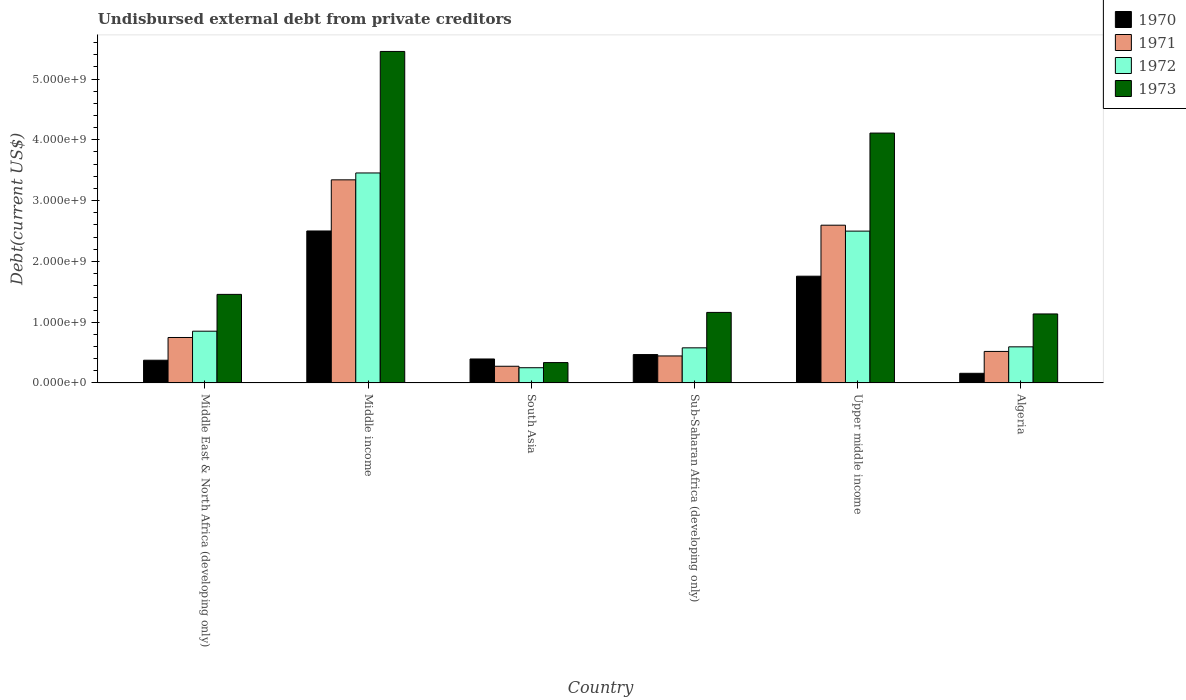Are the number of bars per tick equal to the number of legend labels?
Offer a very short reply. Yes. Are the number of bars on each tick of the X-axis equal?
Give a very brief answer. Yes. How many bars are there on the 5th tick from the right?
Offer a very short reply. 4. What is the label of the 6th group of bars from the left?
Ensure brevity in your answer.  Algeria. What is the total debt in 1973 in Middle East & North Africa (developing only)?
Give a very brief answer. 1.46e+09. Across all countries, what is the maximum total debt in 1973?
Ensure brevity in your answer.  5.45e+09. Across all countries, what is the minimum total debt in 1970?
Ensure brevity in your answer.  1.59e+08. In which country was the total debt in 1973 maximum?
Give a very brief answer. Middle income. In which country was the total debt in 1971 minimum?
Your answer should be compact. South Asia. What is the total total debt in 1970 in the graph?
Your response must be concise. 5.65e+09. What is the difference between the total debt in 1971 in South Asia and that in Upper middle income?
Your answer should be very brief. -2.32e+09. What is the difference between the total debt in 1973 in South Asia and the total debt in 1971 in Middle income?
Make the answer very short. -3.01e+09. What is the average total debt in 1972 per country?
Make the answer very short. 1.37e+09. What is the difference between the total debt of/in 1971 and total debt of/in 1970 in Upper middle income?
Your answer should be compact. 8.39e+08. In how many countries, is the total debt in 1973 greater than 2600000000 US$?
Ensure brevity in your answer.  2. What is the ratio of the total debt in 1972 in Middle income to that in Upper middle income?
Keep it short and to the point. 1.38. Is the difference between the total debt in 1971 in Middle East & North Africa (developing only) and Middle income greater than the difference between the total debt in 1970 in Middle East & North Africa (developing only) and Middle income?
Your answer should be compact. No. What is the difference between the highest and the second highest total debt in 1971?
Provide a short and direct response. -7.46e+08. What is the difference between the highest and the lowest total debt in 1971?
Make the answer very short. 3.07e+09. Is the sum of the total debt in 1971 in South Asia and Upper middle income greater than the maximum total debt in 1970 across all countries?
Keep it short and to the point. Yes. What does the 3rd bar from the left in Upper middle income represents?
Keep it short and to the point. 1972. What does the 4th bar from the right in South Asia represents?
Your response must be concise. 1970. Is it the case that in every country, the sum of the total debt in 1973 and total debt in 1970 is greater than the total debt in 1971?
Make the answer very short. Yes. What is the difference between two consecutive major ticks on the Y-axis?
Offer a terse response. 1.00e+09. Does the graph contain any zero values?
Your answer should be compact. No. Where does the legend appear in the graph?
Provide a short and direct response. Top right. How are the legend labels stacked?
Ensure brevity in your answer.  Vertical. What is the title of the graph?
Your answer should be compact. Undisbursed external debt from private creditors. Does "1968" appear as one of the legend labels in the graph?
Provide a succinct answer. No. What is the label or title of the X-axis?
Your answer should be compact. Country. What is the label or title of the Y-axis?
Make the answer very short. Debt(current US$). What is the Debt(current US$) in 1970 in Middle East & North Africa (developing only)?
Your response must be concise. 3.74e+08. What is the Debt(current US$) of 1971 in Middle East & North Africa (developing only)?
Offer a very short reply. 7.48e+08. What is the Debt(current US$) of 1972 in Middle East & North Africa (developing only)?
Offer a terse response. 8.51e+08. What is the Debt(current US$) in 1973 in Middle East & North Africa (developing only)?
Provide a succinct answer. 1.46e+09. What is the Debt(current US$) of 1970 in Middle income?
Ensure brevity in your answer.  2.50e+09. What is the Debt(current US$) of 1971 in Middle income?
Keep it short and to the point. 3.34e+09. What is the Debt(current US$) of 1972 in Middle income?
Offer a very short reply. 3.45e+09. What is the Debt(current US$) of 1973 in Middle income?
Your answer should be very brief. 5.45e+09. What is the Debt(current US$) of 1970 in South Asia?
Keep it short and to the point. 3.94e+08. What is the Debt(current US$) in 1971 in South Asia?
Provide a succinct answer. 2.74e+08. What is the Debt(current US$) in 1972 in South Asia?
Your answer should be compact. 2.50e+08. What is the Debt(current US$) of 1973 in South Asia?
Offer a terse response. 3.35e+08. What is the Debt(current US$) of 1970 in Sub-Saharan Africa (developing only)?
Offer a very short reply. 4.67e+08. What is the Debt(current US$) of 1971 in Sub-Saharan Africa (developing only)?
Make the answer very short. 4.44e+08. What is the Debt(current US$) of 1972 in Sub-Saharan Africa (developing only)?
Give a very brief answer. 5.77e+08. What is the Debt(current US$) in 1973 in Sub-Saharan Africa (developing only)?
Offer a very short reply. 1.16e+09. What is the Debt(current US$) of 1970 in Upper middle income?
Provide a short and direct response. 1.76e+09. What is the Debt(current US$) of 1971 in Upper middle income?
Give a very brief answer. 2.60e+09. What is the Debt(current US$) of 1972 in Upper middle income?
Offer a very short reply. 2.50e+09. What is the Debt(current US$) in 1973 in Upper middle income?
Your response must be concise. 4.11e+09. What is the Debt(current US$) of 1970 in Algeria?
Your response must be concise. 1.59e+08. What is the Debt(current US$) of 1971 in Algeria?
Keep it short and to the point. 5.18e+08. What is the Debt(current US$) in 1972 in Algeria?
Give a very brief answer. 5.94e+08. What is the Debt(current US$) of 1973 in Algeria?
Offer a very short reply. 1.14e+09. Across all countries, what is the maximum Debt(current US$) of 1970?
Offer a very short reply. 2.50e+09. Across all countries, what is the maximum Debt(current US$) of 1971?
Your answer should be very brief. 3.34e+09. Across all countries, what is the maximum Debt(current US$) of 1972?
Provide a succinct answer. 3.45e+09. Across all countries, what is the maximum Debt(current US$) in 1973?
Ensure brevity in your answer.  5.45e+09. Across all countries, what is the minimum Debt(current US$) in 1970?
Your response must be concise. 1.59e+08. Across all countries, what is the minimum Debt(current US$) in 1971?
Your response must be concise. 2.74e+08. Across all countries, what is the minimum Debt(current US$) in 1972?
Offer a terse response. 2.50e+08. Across all countries, what is the minimum Debt(current US$) of 1973?
Your answer should be compact. 3.35e+08. What is the total Debt(current US$) of 1970 in the graph?
Give a very brief answer. 5.65e+09. What is the total Debt(current US$) in 1971 in the graph?
Ensure brevity in your answer.  7.92e+09. What is the total Debt(current US$) of 1972 in the graph?
Provide a short and direct response. 8.23e+09. What is the total Debt(current US$) of 1973 in the graph?
Your response must be concise. 1.37e+1. What is the difference between the Debt(current US$) of 1970 in Middle East & North Africa (developing only) and that in Middle income?
Ensure brevity in your answer.  -2.13e+09. What is the difference between the Debt(current US$) of 1971 in Middle East & North Africa (developing only) and that in Middle income?
Your response must be concise. -2.59e+09. What is the difference between the Debt(current US$) of 1972 in Middle East & North Africa (developing only) and that in Middle income?
Provide a short and direct response. -2.60e+09. What is the difference between the Debt(current US$) of 1973 in Middle East & North Africa (developing only) and that in Middle income?
Give a very brief answer. -4.00e+09. What is the difference between the Debt(current US$) in 1970 in Middle East & North Africa (developing only) and that in South Asia?
Ensure brevity in your answer.  -2.07e+07. What is the difference between the Debt(current US$) of 1971 in Middle East & North Africa (developing only) and that in South Asia?
Provide a succinct answer. 4.74e+08. What is the difference between the Debt(current US$) in 1972 in Middle East & North Africa (developing only) and that in South Asia?
Your answer should be compact. 6.01e+08. What is the difference between the Debt(current US$) of 1973 in Middle East & North Africa (developing only) and that in South Asia?
Provide a succinct answer. 1.12e+09. What is the difference between the Debt(current US$) in 1970 in Middle East & North Africa (developing only) and that in Sub-Saharan Africa (developing only)?
Your response must be concise. -9.32e+07. What is the difference between the Debt(current US$) in 1971 in Middle East & North Africa (developing only) and that in Sub-Saharan Africa (developing only)?
Ensure brevity in your answer.  3.04e+08. What is the difference between the Debt(current US$) of 1972 in Middle East & North Africa (developing only) and that in Sub-Saharan Africa (developing only)?
Give a very brief answer. 2.74e+08. What is the difference between the Debt(current US$) of 1973 in Middle East & North Africa (developing only) and that in Sub-Saharan Africa (developing only)?
Provide a succinct answer. 2.97e+08. What is the difference between the Debt(current US$) of 1970 in Middle East & North Africa (developing only) and that in Upper middle income?
Make the answer very short. -1.38e+09. What is the difference between the Debt(current US$) of 1971 in Middle East & North Africa (developing only) and that in Upper middle income?
Your response must be concise. -1.85e+09. What is the difference between the Debt(current US$) of 1972 in Middle East & North Africa (developing only) and that in Upper middle income?
Give a very brief answer. -1.65e+09. What is the difference between the Debt(current US$) of 1973 in Middle East & North Africa (developing only) and that in Upper middle income?
Give a very brief answer. -2.65e+09. What is the difference between the Debt(current US$) in 1970 in Middle East & North Africa (developing only) and that in Algeria?
Offer a terse response. 2.15e+08. What is the difference between the Debt(current US$) in 1971 in Middle East & North Africa (developing only) and that in Algeria?
Give a very brief answer. 2.29e+08. What is the difference between the Debt(current US$) in 1972 in Middle East & North Africa (developing only) and that in Algeria?
Offer a terse response. 2.57e+08. What is the difference between the Debt(current US$) in 1973 in Middle East & North Africa (developing only) and that in Algeria?
Offer a terse response. 3.22e+08. What is the difference between the Debt(current US$) in 1970 in Middle income and that in South Asia?
Your answer should be very brief. 2.11e+09. What is the difference between the Debt(current US$) of 1971 in Middle income and that in South Asia?
Offer a very short reply. 3.07e+09. What is the difference between the Debt(current US$) in 1972 in Middle income and that in South Asia?
Ensure brevity in your answer.  3.20e+09. What is the difference between the Debt(current US$) of 1973 in Middle income and that in South Asia?
Keep it short and to the point. 5.12e+09. What is the difference between the Debt(current US$) in 1970 in Middle income and that in Sub-Saharan Africa (developing only)?
Your answer should be very brief. 2.03e+09. What is the difference between the Debt(current US$) in 1971 in Middle income and that in Sub-Saharan Africa (developing only)?
Your response must be concise. 2.90e+09. What is the difference between the Debt(current US$) in 1972 in Middle income and that in Sub-Saharan Africa (developing only)?
Your response must be concise. 2.88e+09. What is the difference between the Debt(current US$) in 1973 in Middle income and that in Sub-Saharan Africa (developing only)?
Keep it short and to the point. 4.29e+09. What is the difference between the Debt(current US$) in 1970 in Middle income and that in Upper middle income?
Offer a terse response. 7.44e+08. What is the difference between the Debt(current US$) in 1971 in Middle income and that in Upper middle income?
Offer a very short reply. 7.46e+08. What is the difference between the Debt(current US$) in 1972 in Middle income and that in Upper middle income?
Provide a succinct answer. 9.57e+08. What is the difference between the Debt(current US$) in 1973 in Middle income and that in Upper middle income?
Offer a very short reply. 1.34e+09. What is the difference between the Debt(current US$) of 1970 in Middle income and that in Algeria?
Give a very brief answer. 2.34e+09. What is the difference between the Debt(current US$) in 1971 in Middle income and that in Algeria?
Offer a very short reply. 2.82e+09. What is the difference between the Debt(current US$) in 1972 in Middle income and that in Algeria?
Provide a succinct answer. 2.86e+09. What is the difference between the Debt(current US$) of 1973 in Middle income and that in Algeria?
Keep it short and to the point. 4.32e+09. What is the difference between the Debt(current US$) of 1970 in South Asia and that in Sub-Saharan Africa (developing only)?
Make the answer very short. -7.26e+07. What is the difference between the Debt(current US$) of 1971 in South Asia and that in Sub-Saharan Africa (developing only)?
Offer a very short reply. -1.70e+08. What is the difference between the Debt(current US$) of 1972 in South Asia and that in Sub-Saharan Africa (developing only)?
Your answer should be compact. -3.27e+08. What is the difference between the Debt(current US$) of 1973 in South Asia and that in Sub-Saharan Africa (developing only)?
Offer a very short reply. -8.26e+08. What is the difference between the Debt(current US$) in 1970 in South Asia and that in Upper middle income?
Your answer should be very brief. -1.36e+09. What is the difference between the Debt(current US$) of 1971 in South Asia and that in Upper middle income?
Your answer should be compact. -2.32e+09. What is the difference between the Debt(current US$) in 1972 in South Asia and that in Upper middle income?
Your answer should be compact. -2.25e+09. What is the difference between the Debt(current US$) in 1973 in South Asia and that in Upper middle income?
Your answer should be very brief. -3.78e+09. What is the difference between the Debt(current US$) in 1970 in South Asia and that in Algeria?
Ensure brevity in your answer.  2.36e+08. What is the difference between the Debt(current US$) of 1971 in South Asia and that in Algeria?
Keep it short and to the point. -2.44e+08. What is the difference between the Debt(current US$) of 1972 in South Asia and that in Algeria?
Offer a very short reply. -3.44e+08. What is the difference between the Debt(current US$) of 1973 in South Asia and that in Algeria?
Offer a terse response. -8.00e+08. What is the difference between the Debt(current US$) in 1970 in Sub-Saharan Africa (developing only) and that in Upper middle income?
Offer a terse response. -1.29e+09. What is the difference between the Debt(current US$) of 1971 in Sub-Saharan Africa (developing only) and that in Upper middle income?
Offer a very short reply. -2.15e+09. What is the difference between the Debt(current US$) in 1972 in Sub-Saharan Africa (developing only) and that in Upper middle income?
Provide a succinct answer. -1.92e+09. What is the difference between the Debt(current US$) of 1973 in Sub-Saharan Africa (developing only) and that in Upper middle income?
Make the answer very short. -2.95e+09. What is the difference between the Debt(current US$) in 1970 in Sub-Saharan Africa (developing only) and that in Algeria?
Your response must be concise. 3.08e+08. What is the difference between the Debt(current US$) of 1971 in Sub-Saharan Africa (developing only) and that in Algeria?
Your answer should be compact. -7.44e+07. What is the difference between the Debt(current US$) of 1972 in Sub-Saharan Africa (developing only) and that in Algeria?
Provide a succinct answer. -1.64e+07. What is the difference between the Debt(current US$) of 1973 in Sub-Saharan Africa (developing only) and that in Algeria?
Offer a terse response. 2.52e+07. What is the difference between the Debt(current US$) of 1970 in Upper middle income and that in Algeria?
Keep it short and to the point. 1.60e+09. What is the difference between the Debt(current US$) of 1971 in Upper middle income and that in Algeria?
Offer a very short reply. 2.08e+09. What is the difference between the Debt(current US$) in 1972 in Upper middle income and that in Algeria?
Your answer should be very brief. 1.90e+09. What is the difference between the Debt(current US$) of 1973 in Upper middle income and that in Algeria?
Make the answer very short. 2.98e+09. What is the difference between the Debt(current US$) of 1970 in Middle East & North Africa (developing only) and the Debt(current US$) of 1971 in Middle income?
Offer a very short reply. -2.97e+09. What is the difference between the Debt(current US$) of 1970 in Middle East & North Africa (developing only) and the Debt(current US$) of 1972 in Middle income?
Provide a succinct answer. -3.08e+09. What is the difference between the Debt(current US$) in 1970 in Middle East & North Africa (developing only) and the Debt(current US$) in 1973 in Middle income?
Offer a very short reply. -5.08e+09. What is the difference between the Debt(current US$) of 1971 in Middle East & North Africa (developing only) and the Debt(current US$) of 1972 in Middle income?
Provide a succinct answer. -2.71e+09. What is the difference between the Debt(current US$) in 1971 in Middle East & North Africa (developing only) and the Debt(current US$) in 1973 in Middle income?
Offer a terse response. -4.71e+09. What is the difference between the Debt(current US$) in 1972 in Middle East & North Africa (developing only) and the Debt(current US$) in 1973 in Middle income?
Give a very brief answer. -4.60e+09. What is the difference between the Debt(current US$) in 1970 in Middle East & North Africa (developing only) and the Debt(current US$) in 1971 in South Asia?
Provide a short and direct response. 9.92e+07. What is the difference between the Debt(current US$) in 1970 in Middle East & North Africa (developing only) and the Debt(current US$) in 1972 in South Asia?
Provide a short and direct response. 1.23e+08. What is the difference between the Debt(current US$) in 1970 in Middle East & North Africa (developing only) and the Debt(current US$) in 1973 in South Asia?
Give a very brief answer. 3.88e+07. What is the difference between the Debt(current US$) of 1971 in Middle East & North Africa (developing only) and the Debt(current US$) of 1972 in South Asia?
Your response must be concise. 4.98e+08. What is the difference between the Debt(current US$) in 1971 in Middle East & North Africa (developing only) and the Debt(current US$) in 1973 in South Asia?
Your response must be concise. 4.13e+08. What is the difference between the Debt(current US$) of 1972 in Middle East & North Africa (developing only) and the Debt(current US$) of 1973 in South Asia?
Give a very brief answer. 5.17e+08. What is the difference between the Debt(current US$) of 1970 in Middle East & North Africa (developing only) and the Debt(current US$) of 1971 in Sub-Saharan Africa (developing only)?
Keep it short and to the point. -7.04e+07. What is the difference between the Debt(current US$) of 1970 in Middle East & North Africa (developing only) and the Debt(current US$) of 1972 in Sub-Saharan Africa (developing only)?
Your answer should be compact. -2.04e+08. What is the difference between the Debt(current US$) of 1970 in Middle East & North Africa (developing only) and the Debt(current US$) of 1973 in Sub-Saharan Africa (developing only)?
Offer a terse response. -7.87e+08. What is the difference between the Debt(current US$) of 1971 in Middle East & North Africa (developing only) and the Debt(current US$) of 1972 in Sub-Saharan Africa (developing only)?
Your response must be concise. 1.70e+08. What is the difference between the Debt(current US$) in 1971 in Middle East & North Africa (developing only) and the Debt(current US$) in 1973 in Sub-Saharan Africa (developing only)?
Your response must be concise. -4.12e+08. What is the difference between the Debt(current US$) of 1972 in Middle East & North Africa (developing only) and the Debt(current US$) of 1973 in Sub-Saharan Africa (developing only)?
Keep it short and to the point. -3.09e+08. What is the difference between the Debt(current US$) of 1970 in Middle East & North Africa (developing only) and the Debt(current US$) of 1971 in Upper middle income?
Offer a very short reply. -2.22e+09. What is the difference between the Debt(current US$) in 1970 in Middle East & North Africa (developing only) and the Debt(current US$) in 1972 in Upper middle income?
Provide a succinct answer. -2.12e+09. What is the difference between the Debt(current US$) in 1970 in Middle East & North Africa (developing only) and the Debt(current US$) in 1973 in Upper middle income?
Give a very brief answer. -3.74e+09. What is the difference between the Debt(current US$) of 1971 in Middle East & North Africa (developing only) and the Debt(current US$) of 1972 in Upper middle income?
Your answer should be very brief. -1.75e+09. What is the difference between the Debt(current US$) of 1971 in Middle East & North Africa (developing only) and the Debt(current US$) of 1973 in Upper middle income?
Provide a succinct answer. -3.36e+09. What is the difference between the Debt(current US$) of 1972 in Middle East & North Africa (developing only) and the Debt(current US$) of 1973 in Upper middle income?
Your answer should be compact. -3.26e+09. What is the difference between the Debt(current US$) in 1970 in Middle East & North Africa (developing only) and the Debt(current US$) in 1971 in Algeria?
Give a very brief answer. -1.45e+08. What is the difference between the Debt(current US$) in 1970 in Middle East & North Africa (developing only) and the Debt(current US$) in 1972 in Algeria?
Your response must be concise. -2.20e+08. What is the difference between the Debt(current US$) in 1970 in Middle East & North Africa (developing only) and the Debt(current US$) in 1973 in Algeria?
Ensure brevity in your answer.  -7.62e+08. What is the difference between the Debt(current US$) in 1971 in Middle East & North Africa (developing only) and the Debt(current US$) in 1972 in Algeria?
Provide a succinct answer. 1.54e+08. What is the difference between the Debt(current US$) in 1971 in Middle East & North Africa (developing only) and the Debt(current US$) in 1973 in Algeria?
Your answer should be very brief. -3.87e+08. What is the difference between the Debt(current US$) in 1972 in Middle East & North Africa (developing only) and the Debt(current US$) in 1973 in Algeria?
Your response must be concise. -2.84e+08. What is the difference between the Debt(current US$) of 1970 in Middle income and the Debt(current US$) of 1971 in South Asia?
Keep it short and to the point. 2.23e+09. What is the difference between the Debt(current US$) in 1970 in Middle income and the Debt(current US$) in 1972 in South Asia?
Provide a succinct answer. 2.25e+09. What is the difference between the Debt(current US$) in 1970 in Middle income and the Debt(current US$) in 1973 in South Asia?
Offer a terse response. 2.17e+09. What is the difference between the Debt(current US$) of 1971 in Middle income and the Debt(current US$) of 1972 in South Asia?
Your answer should be very brief. 3.09e+09. What is the difference between the Debt(current US$) of 1971 in Middle income and the Debt(current US$) of 1973 in South Asia?
Ensure brevity in your answer.  3.01e+09. What is the difference between the Debt(current US$) in 1972 in Middle income and the Debt(current US$) in 1973 in South Asia?
Make the answer very short. 3.12e+09. What is the difference between the Debt(current US$) in 1970 in Middle income and the Debt(current US$) in 1971 in Sub-Saharan Africa (developing only)?
Provide a short and direct response. 2.06e+09. What is the difference between the Debt(current US$) of 1970 in Middle income and the Debt(current US$) of 1972 in Sub-Saharan Africa (developing only)?
Offer a terse response. 1.92e+09. What is the difference between the Debt(current US$) of 1970 in Middle income and the Debt(current US$) of 1973 in Sub-Saharan Africa (developing only)?
Your answer should be compact. 1.34e+09. What is the difference between the Debt(current US$) in 1971 in Middle income and the Debt(current US$) in 1972 in Sub-Saharan Africa (developing only)?
Make the answer very short. 2.76e+09. What is the difference between the Debt(current US$) of 1971 in Middle income and the Debt(current US$) of 1973 in Sub-Saharan Africa (developing only)?
Keep it short and to the point. 2.18e+09. What is the difference between the Debt(current US$) of 1972 in Middle income and the Debt(current US$) of 1973 in Sub-Saharan Africa (developing only)?
Your answer should be compact. 2.29e+09. What is the difference between the Debt(current US$) in 1970 in Middle income and the Debt(current US$) in 1971 in Upper middle income?
Offer a very short reply. -9.50e+07. What is the difference between the Debt(current US$) of 1970 in Middle income and the Debt(current US$) of 1972 in Upper middle income?
Give a very brief answer. 2.49e+06. What is the difference between the Debt(current US$) of 1970 in Middle income and the Debt(current US$) of 1973 in Upper middle income?
Offer a very short reply. -1.61e+09. What is the difference between the Debt(current US$) of 1971 in Middle income and the Debt(current US$) of 1972 in Upper middle income?
Your answer should be very brief. 8.44e+08. What is the difference between the Debt(current US$) in 1971 in Middle income and the Debt(current US$) in 1973 in Upper middle income?
Provide a succinct answer. -7.70e+08. What is the difference between the Debt(current US$) of 1972 in Middle income and the Debt(current US$) of 1973 in Upper middle income?
Ensure brevity in your answer.  -6.57e+08. What is the difference between the Debt(current US$) of 1970 in Middle income and the Debt(current US$) of 1971 in Algeria?
Your answer should be compact. 1.98e+09. What is the difference between the Debt(current US$) in 1970 in Middle income and the Debt(current US$) in 1972 in Algeria?
Provide a short and direct response. 1.91e+09. What is the difference between the Debt(current US$) in 1970 in Middle income and the Debt(current US$) in 1973 in Algeria?
Your answer should be compact. 1.37e+09. What is the difference between the Debt(current US$) of 1971 in Middle income and the Debt(current US$) of 1972 in Algeria?
Make the answer very short. 2.75e+09. What is the difference between the Debt(current US$) of 1971 in Middle income and the Debt(current US$) of 1973 in Algeria?
Make the answer very short. 2.21e+09. What is the difference between the Debt(current US$) of 1972 in Middle income and the Debt(current US$) of 1973 in Algeria?
Give a very brief answer. 2.32e+09. What is the difference between the Debt(current US$) of 1970 in South Asia and the Debt(current US$) of 1971 in Sub-Saharan Africa (developing only)?
Your answer should be very brief. -4.98e+07. What is the difference between the Debt(current US$) in 1970 in South Asia and the Debt(current US$) in 1972 in Sub-Saharan Africa (developing only)?
Ensure brevity in your answer.  -1.83e+08. What is the difference between the Debt(current US$) of 1970 in South Asia and the Debt(current US$) of 1973 in Sub-Saharan Africa (developing only)?
Ensure brevity in your answer.  -7.66e+08. What is the difference between the Debt(current US$) of 1971 in South Asia and the Debt(current US$) of 1972 in Sub-Saharan Africa (developing only)?
Keep it short and to the point. -3.03e+08. What is the difference between the Debt(current US$) of 1971 in South Asia and the Debt(current US$) of 1973 in Sub-Saharan Africa (developing only)?
Provide a short and direct response. -8.86e+08. What is the difference between the Debt(current US$) of 1972 in South Asia and the Debt(current US$) of 1973 in Sub-Saharan Africa (developing only)?
Give a very brief answer. -9.10e+08. What is the difference between the Debt(current US$) of 1970 in South Asia and the Debt(current US$) of 1971 in Upper middle income?
Your response must be concise. -2.20e+09. What is the difference between the Debt(current US$) of 1970 in South Asia and the Debt(current US$) of 1972 in Upper middle income?
Make the answer very short. -2.10e+09. What is the difference between the Debt(current US$) of 1970 in South Asia and the Debt(current US$) of 1973 in Upper middle income?
Provide a succinct answer. -3.72e+09. What is the difference between the Debt(current US$) in 1971 in South Asia and the Debt(current US$) in 1972 in Upper middle income?
Your answer should be very brief. -2.22e+09. What is the difference between the Debt(current US$) of 1971 in South Asia and the Debt(current US$) of 1973 in Upper middle income?
Provide a succinct answer. -3.84e+09. What is the difference between the Debt(current US$) of 1972 in South Asia and the Debt(current US$) of 1973 in Upper middle income?
Provide a short and direct response. -3.86e+09. What is the difference between the Debt(current US$) of 1970 in South Asia and the Debt(current US$) of 1971 in Algeria?
Provide a short and direct response. -1.24e+08. What is the difference between the Debt(current US$) of 1970 in South Asia and the Debt(current US$) of 1972 in Algeria?
Make the answer very short. -2.00e+08. What is the difference between the Debt(current US$) in 1970 in South Asia and the Debt(current US$) in 1973 in Algeria?
Make the answer very short. -7.41e+08. What is the difference between the Debt(current US$) of 1971 in South Asia and the Debt(current US$) of 1972 in Algeria?
Your answer should be compact. -3.20e+08. What is the difference between the Debt(current US$) of 1971 in South Asia and the Debt(current US$) of 1973 in Algeria?
Provide a succinct answer. -8.61e+08. What is the difference between the Debt(current US$) of 1972 in South Asia and the Debt(current US$) of 1973 in Algeria?
Offer a terse response. -8.85e+08. What is the difference between the Debt(current US$) of 1970 in Sub-Saharan Africa (developing only) and the Debt(current US$) of 1971 in Upper middle income?
Provide a succinct answer. -2.13e+09. What is the difference between the Debt(current US$) of 1970 in Sub-Saharan Africa (developing only) and the Debt(current US$) of 1972 in Upper middle income?
Provide a short and direct response. -2.03e+09. What is the difference between the Debt(current US$) of 1970 in Sub-Saharan Africa (developing only) and the Debt(current US$) of 1973 in Upper middle income?
Make the answer very short. -3.64e+09. What is the difference between the Debt(current US$) of 1971 in Sub-Saharan Africa (developing only) and the Debt(current US$) of 1972 in Upper middle income?
Make the answer very short. -2.05e+09. What is the difference between the Debt(current US$) in 1971 in Sub-Saharan Africa (developing only) and the Debt(current US$) in 1973 in Upper middle income?
Keep it short and to the point. -3.67e+09. What is the difference between the Debt(current US$) in 1972 in Sub-Saharan Africa (developing only) and the Debt(current US$) in 1973 in Upper middle income?
Ensure brevity in your answer.  -3.53e+09. What is the difference between the Debt(current US$) of 1970 in Sub-Saharan Africa (developing only) and the Debt(current US$) of 1971 in Algeria?
Provide a succinct answer. -5.16e+07. What is the difference between the Debt(current US$) in 1970 in Sub-Saharan Africa (developing only) and the Debt(current US$) in 1972 in Algeria?
Your response must be concise. -1.27e+08. What is the difference between the Debt(current US$) in 1970 in Sub-Saharan Africa (developing only) and the Debt(current US$) in 1973 in Algeria?
Your response must be concise. -6.68e+08. What is the difference between the Debt(current US$) of 1971 in Sub-Saharan Africa (developing only) and the Debt(current US$) of 1972 in Algeria?
Offer a terse response. -1.50e+08. What is the difference between the Debt(current US$) of 1971 in Sub-Saharan Africa (developing only) and the Debt(current US$) of 1973 in Algeria?
Offer a very short reply. -6.91e+08. What is the difference between the Debt(current US$) of 1972 in Sub-Saharan Africa (developing only) and the Debt(current US$) of 1973 in Algeria?
Provide a short and direct response. -5.58e+08. What is the difference between the Debt(current US$) of 1970 in Upper middle income and the Debt(current US$) of 1971 in Algeria?
Offer a very short reply. 1.24e+09. What is the difference between the Debt(current US$) of 1970 in Upper middle income and the Debt(current US$) of 1972 in Algeria?
Provide a short and direct response. 1.16e+09. What is the difference between the Debt(current US$) of 1970 in Upper middle income and the Debt(current US$) of 1973 in Algeria?
Provide a succinct answer. 6.21e+08. What is the difference between the Debt(current US$) of 1971 in Upper middle income and the Debt(current US$) of 1972 in Algeria?
Offer a very short reply. 2.00e+09. What is the difference between the Debt(current US$) of 1971 in Upper middle income and the Debt(current US$) of 1973 in Algeria?
Offer a terse response. 1.46e+09. What is the difference between the Debt(current US$) of 1972 in Upper middle income and the Debt(current US$) of 1973 in Algeria?
Give a very brief answer. 1.36e+09. What is the average Debt(current US$) of 1970 per country?
Offer a very short reply. 9.42e+08. What is the average Debt(current US$) of 1971 per country?
Your response must be concise. 1.32e+09. What is the average Debt(current US$) in 1972 per country?
Make the answer very short. 1.37e+09. What is the average Debt(current US$) of 1973 per country?
Provide a short and direct response. 2.28e+09. What is the difference between the Debt(current US$) in 1970 and Debt(current US$) in 1971 in Middle East & North Africa (developing only)?
Your answer should be very brief. -3.74e+08. What is the difference between the Debt(current US$) of 1970 and Debt(current US$) of 1972 in Middle East & North Africa (developing only)?
Offer a terse response. -4.78e+08. What is the difference between the Debt(current US$) in 1970 and Debt(current US$) in 1973 in Middle East & North Africa (developing only)?
Your response must be concise. -1.08e+09. What is the difference between the Debt(current US$) in 1971 and Debt(current US$) in 1972 in Middle East & North Africa (developing only)?
Your response must be concise. -1.04e+08. What is the difference between the Debt(current US$) of 1971 and Debt(current US$) of 1973 in Middle East & North Africa (developing only)?
Your answer should be compact. -7.09e+08. What is the difference between the Debt(current US$) in 1972 and Debt(current US$) in 1973 in Middle East & North Africa (developing only)?
Keep it short and to the point. -6.06e+08. What is the difference between the Debt(current US$) in 1970 and Debt(current US$) in 1971 in Middle income?
Your response must be concise. -8.41e+08. What is the difference between the Debt(current US$) of 1970 and Debt(current US$) of 1972 in Middle income?
Your answer should be very brief. -9.54e+08. What is the difference between the Debt(current US$) in 1970 and Debt(current US$) in 1973 in Middle income?
Provide a succinct answer. -2.95e+09. What is the difference between the Debt(current US$) of 1971 and Debt(current US$) of 1972 in Middle income?
Offer a very short reply. -1.13e+08. What is the difference between the Debt(current US$) in 1971 and Debt(current US$) in 1973 in Middle income?
Provide a short and direct response. -2.11e+09. What is the difference between the Debt(current US$) of 1972 and Debt(current US$) of 1973 in Middle income?
Provide a short and direct response. -2.00e+09. What is the difference between the Debt(current US$) of 1970 and Debt(current US$) of 1971 in South Asia?
Give a very brief answer. 1.20e+08. What is the difference between the Debt(current US$) in 1970 and Debt(current US$) in 1972 in South Asia?
Your answer should be very brief. 1.44e+08. What is the difference between the Debt(current US$) of 1970 and Debt(current US$) of 1973 in South Asia?
Make the answer very short. 5.95e+07. What is the difference between the Debt(current US$) of 1971 and Debt(current US$) of 1972 in South Asia?
Your answer should be compact. 2.41e+07. What is the difference between the Debt(current US$) in 1971 and Debt(current US$) in 1973 in South Asia?
Your answer should be very brief. -6.04e+07. What is the difference between the Debt(current US$) of 1972 and Debt(current US$) of 1973 in South Asia?
Offer a terse response. -8.45e+07. What is the difference between the Debt(current US$) in 1970 and Debt(current US$) in 1971 in Sub-Saharan Africa (developing only)?
Ensure brevity in your answer.  2.28e+07. What is the difference between the Debt(current US$) in 1970 and Debt(current US$) in 1972 in Sub-Saharan Africa (developing only)?
Give a very brief answer. -1.11e+08. What is the difference between the Debt(current US$) of 1970 and Debt(current US$) of 1973 in Sub-Saharan Africa (developing only)?
Keep it short and to the point. -6.94e+08. What is the difference between the Debt(current US$) of 1971 and Debt(current US$) of 1972 in Sub-Saharan Africa (developing only)?
Your response must be concise. -1.33e+08. What is the difference between the Debt(current US$) in 1971 and Debt(current US$) in 1973 in Sub-Saharan Africa (developing only)?
Make the answer very short. -7.16e+08. What is the difference between the Debt(current US$) in 1972 and Debt(current US$) in 1973 in Sub-Saharan Africa (developing only)?
Ensure brevity in your answer.  -5.83e+08. What is the difference between the Debt(current US$) in 1970 and Debt(current US$) in 1971 in Upper middle income?
Your answer should be compact. -8.39e+08. What is the difference between the Debt(current US$) of 1970 and Debt(current US$) of 1972 in Upper middle income?
Provide a succinct answer. -7.42e+08. What is the difference between the Debt(current US$) of 1970 and Debt(current US$) of 1973 in Upper middle income?
Keep it short and to the point. -2.36e+09. What is the difference between the Debt(current US$) in 1971 and Debt(current US$) in 1972 in Upper middle income?
Your answer should be compact. 9.75e+07. What is the difference between the Debt(current US$) in 1971 and Debt(current US$) in 1973 in Upper middle income?
Your answer should be compact. -1.52e+09. What is the difference between the Debt(current US$) of 1972 and Debt(current US$) of 1973 in Upper middle income?
Make the answer very short. -1.61e+09. What is the difference between the Debt(current US$) of 1970 and Debt(current US$) of 1971 in Algeria?
Keep it short and to the point. -3.60e+08. What is the difference between the Debt(current US$) in 1970 and Debt(current US$) in 1972 in Algeria?
Make the answer very short. -4.35e+08. What is the difference between the Debt(current US$) of 1970 and Debt(current US$) of 1973 in Algeria?
Your answer should be compact. -9.77e+08. What is the difference between the Debt(current US$) of 1971 and Debt(current US$) of 1972 in Algeria?
Provide a succinct answer. -7.55e+07. What is the difference between the Debt(current US$) of 1971 and Debt(current US$) of 1973 in Algeria?
Provide a short and direct response. -6.17e+08. What is the difference between the Debt(current US$) in 1972 and Debt(current US$) in 1973 in Algeria?
Your response must be concise. -5.41e+08. What is the ratio of the Debt(current US$) in 1970 in Middle East & North Africa (developing only) to that in Middle income?
Provide a succinct answer. 0.15. What is the ratio of the Debt(current US$) in 1971 in Middle East & North Africa (developing only) to that in Middle income?
Keep it short and to the point. 0.22. What is the ratio of the Debt(current US$) of 1972 in Middle East & North Africa (developing only) to that in Middle income?
Provide a succinct answer. 0.25. What is the ratio of the Debt(current US$) in 1973 in Middle East & North Africa (developing only) to that in Middle income?
Offer a terse response. 0.27. What is the ratio of the Debt(current US$) in 1970 in Middle East & North Africa (developing only) to that in South Asia?
Offer a very short reply. 0.95. What is the ratio of the Debt(current US$) in 1971 in Middle East & North Africa (developing only) to that in South Asia?
Make the answer very short. 2.73. What is the ratio of the Debt(current US$) of 1972 in Middle East & North Africa (developing only) to that in South Asia?
Offer a very short reply. 3.4. What is the ratio of the Debt(current US$) in 1973 in Middle East & North Africa (developing only) to that in South Asia?
Provide a succinct answer. 4.35. What is the ratio of the Debt(current US$) of 1970 in Middle East & North Africa (developing only) to that in Sub-Saharan Africa (developing only)?
Make the answer very short. 0.8. What is the ratio of the Debt(current US$) in 1971 in Middle East & North Africa (developing only) to that in Sub-Saharan Africa (developing only)?
Make the answer very short. 1.68. What is the ratio of the Debt(current US$) in 1972 in Middle East & North Africa (developing only) to that in Sub-Saharan Africa (developing only)?
Offer a very short reply. 1.47. What is the ratio of the Debt(current US$) in 1973 in Middle East & North Africa (developing only) to that in Sub-Saharan Africa (developing only)?
Offer a terse response. 1.26. What is the ratio of the Debt(current US$) in 1970 in Middle East & North Africa (developing only) to that in Upper middle income?
Keep it short and to the point. 0.21. What is the ratio of the Debt(current US$) in 1971 in Middle East & North Africa (developing only) to that in Upper middle income?
Your response must be concise. 0.29. What is the ratio of the Debt(current US$) of 1972 in Middle East & North Africa (developing only) to that in Upper middle income?
Ensure brevity in your answer.  0.34. What is the ratio of the Debt(current US$) in 1973 in Middle East & North Africa (developing only) to that in Upper middle income?
Give a very brief answer. 0.35. What is the ratio of the Debt(current US$) in 1970 in Middle East & North Africa (developing only) to that in Algeria?
Ensure brevity in your answer.  2.36. What is the ratio of the Debt(current US$) in 1971 in Middle East & North Africa (developing only) to that in Algeria?
Provide a short and direct response. 1.44. What is the ratio of the Debt(current US$) of 1972 in Middle East & North Africa (developing only) to that in Algeria?
Keep it short and to the point. 1.43. What is the ratio of the Debt(current US$) in 1973 in Middle East & North Africa (developing only) to that in Algeria?
Give a very brief answer. 1.28. What is the ratio of the Debt(current US$) of 1970 in Middle income to that in South Asia?
Ensure brevity in your answer.  6.34. What is the ratio of the Debt(current US$) of 1971 in Middle income to that in South Asia?
Give a very brief answer. 12.18. What is the ratio of the Debt(current US$) in 1972 in Middle income to that in South Asia?
Ensure brevity in your answer.  13.8. What is the ratio of the Debt(current US$) in 1973 in Middle income to that in South Asia?
Ensure brevity in your answer.  16.29. What is the ratio of the Debt(current US$) of 1970 in Middle income to that in Sub-Saharan Africa (developing only)?
Give a very brief answer. 5.36. What is the ratio of the Debt(current US$) in 1971 in Middle income to that in Sub-Saharan Africa (developing only)?
Offer a terse response. 7.53. What is the ratio of the Debt(current US$) of 1972 in Middle income to that in Sub-Saharan Africa (developing only)?
Your answer should be compact. 5.98. What is the ratio of the Debt(current US$) in 1973 in Middle income to that in Sub-Saharan Africa (developing only)?
Keep it short and to the point. 4.7. What is the ratio of the Debt(current US$) in 1970 in Middle income to that in Upper middle income?
Offer a terse response. 1.42. What is the ratio of the Debt(current US$) in 1971 in Middle income to that in Upper middle income?
Provide a succinct answer. 1.29. What is the ratio of the Debt(current US$) of 1972 in Middle income to that in Upper middle income?
Ensure brevity in your answer.  1.38. What is the ratio of the Debt(current US$) of 1973 in Middle income to that in Upper middle income?
Make the answer very short. 1.33. What is the ratio of the Debt(current US$) of 1970 in Middle income to that in Algeria?
Offer a very short reply. 15.77. What is the ratio of the Debt(current US$) of 1971 in Middle income to that in Algeria?
Keep it short and to the point. 6.45. What is the ratio of the Debt(current US$) of 1972 in Middle income to that in Algeria?
Make the answer very short. 5.82. What is the ratio of the Debt(current US$) of 1973 in Middle income to that in Algeria?
Ensure brevity in your answer.  4.8. What is the ratio of the Debt(current US$) in 1970 in South Asia to that in Sub-Saharan Africa (developing only)?
Keep it short and to the point. 0.84. What is the ratio of the Debt(current US$) in 1971 in South Asia to that in Sub-Saharan Africa (developing only)?
Your answer should be very brief. 0.62. What is the ratio of the Debt(current US$) of 1972 in South Asia to that in Sub-Saharan Africa (developing only)?
Offer a very short reply. 0.43. What is the ratio of the Debt(current US$) of 1973 in South Asia to that in Sub-Saharan Africa (developing only)?
Ensure brevity in your answer.  0.29. What is the ratio of the Debt(current US$) in 1970 in South Asia to that in Upper middle income?
Your answer should be compact. 0.22. What is the ratio of the Debt(current US$) of 1971 in South Asia to that in Upper middle income?
Give a very brief answer. 0.11. What is the ratio of the Debt(current US$) in 1972 in South Asia to that in Upper middle income?
Make the answer very short. 0.1. What is the ratio of the Debt(current US$) of 1973 in South Asia to that in Upper middle income?
Ensure brevity in your answer.  0.08. What is the ratio of the Debt(current US$) in 1970 in South Asia to that in Algeria?
Your response must be concise. 2.49. What is the ratio of the Debt(current US$) in 1971 in South Asia to that in Algeria?
Provide a short and direct response. 0.53. What is the ratio of the Debt(current US$) in 1972 in South Asia to that in Algeria?
Ensure brevity in your answer.  0.42. What is the ratio of the Debt(current US$) in 1973 in South Asia to that in Algeria?
Your answer should be very brief. 0.29. What is the ratio of the Debt(current US$) in 1970 in Sub-Saharan Africa (developing only) to that in Upper middle income?
Provide a short and direct response. 0.27. What is the ratio of the Debt(current US$) in 1971 in Sub-Saharan Africa (developing only) to that in Upper middle income?
Give a very brief answer. 0.17. What is the ratio of the Debt(current US$) in 1972 in Sub-Saharan Africa (developing only) to that in Upper middle income?
Make the answer very short. 0.23. What is the ratio of the Debt(current US$) in 1973 in Sub-Saharan Africa (developing only) to that in Upper middle income?
Your answer should be very brief. 0.28. What is the ratio of the Debt(current US$) in 1970 in Sub-Saharan Africa (developing only) to that in Algeria?
Your answer should be compact. 2.94. What is the ratio of the Debt(current US$) in 1971 in Sub-Saharan Africa (developing only) to that in Algeria?
Provide a short and direct response. 0.86. What is the ratio of the Debt(current US$) in 1972 in Sub-Saharan Africa (developing only) to that in Algeria?
Provide a short and direct response. 0.97. What is the ratio of the Debt(current US$) in 1973 in Sub-Saharan Africa (developing only) to that in Algeria?
Your response must be concise. 1.02. What is the ratio of the Debt(current US$) in 1970 in Upper middle income to that in Algeria?
Provide a short and direct response. 11.08. What is the ratio of the Debt(current US$) in 1971 in Upper middle income to that in Algeria?
Provide a succinct answer. 5.01. What is the ratio of the Debt(current US$) of 1972 in Upper middle income to that in Algeria?
Your answer should be very brief. 4.21. What is the ratio of the Debt(current US$) in 1973 in Upper middle income to that in Algeria?
Your answer should be very brief. 3.62. What is the difference between the highest and the second highest Debt(current US$) of 1970?
Provide a short and direct response. 7.44e+08. What is the difference between the highest and the second highest Debt(current US$) in 1971?
Offer a very short reply. 7.46e+08. What is the difference between the highest and the second highest Debt(current US$) in 1972?
Your answer should be compact. 9.57e+08. What is the difference between the highest and the second highest Debt(current US$) of 1973?
Offer a very short reply. 1.34e+09. What is the difference between the highest and the lowest Debt(current US$) of 1970?
Offer a very short reply. 2.34e+09. What is the difference between the highest and the lowest Debt(current US$) of 1971?
Give a very brief answer. 3.07e+09. What is the difference between the highest and the lowest Debt(current US$) of 1972?
Provide a short and direct response. 3.20e+09. What is the difference between the highest and the lowest Debt(current US$) in 1973?
Provide a short and direct response. 5.12e+09. 